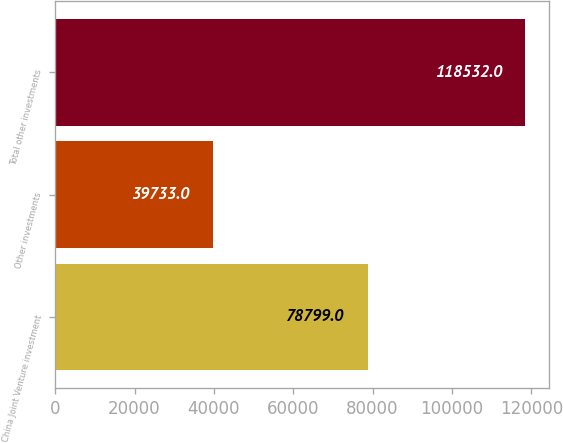Convert chart. <chart><loc_0><loc_0><loc_500><loc_500><bar_chart><fcel>China Joint Venture investment<fcel>Other investments<fcel>Total other investments<nl><fcel>78799<fcel>39733<fcel>118532<nl></chart> 